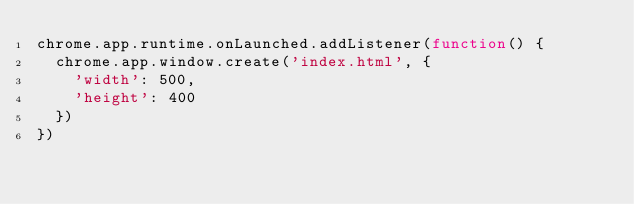Convert code to text. <code><loc_0><loc_0><loc_500><loc_500><_JavaScript_>chrome.app.runtime.onLaunched.addListener(function() {
  chrome.app.window.create('index.html', {
    'width': 500,
    'height': 400
  })
})
</code> 